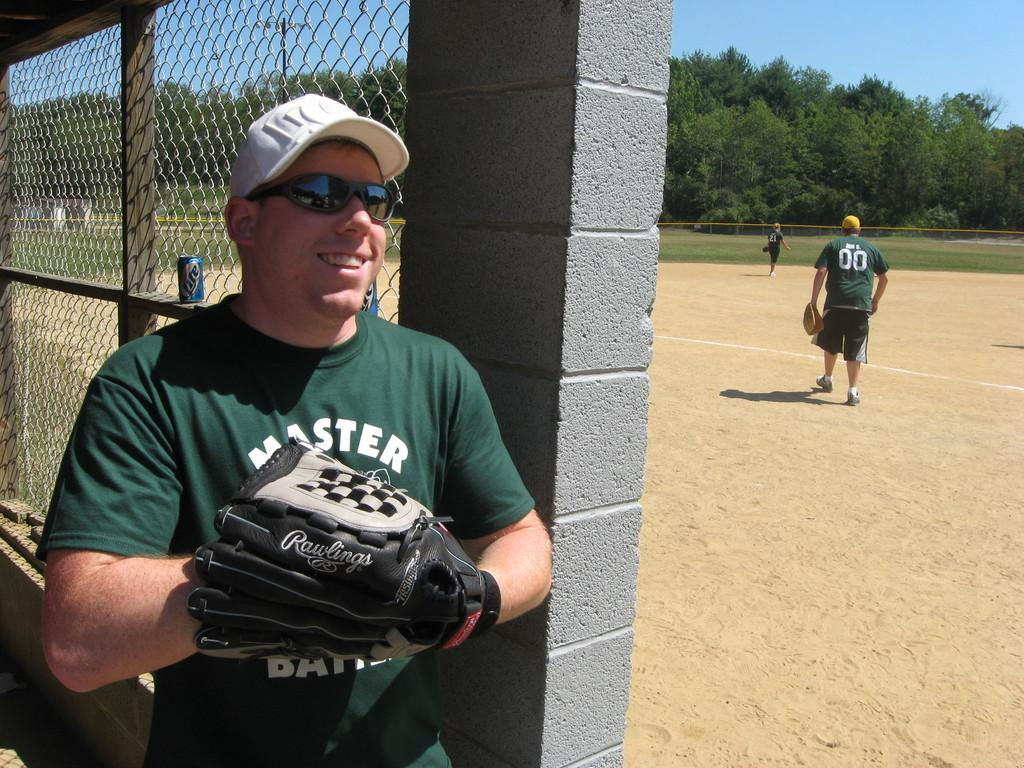<image>
Relay a brief, clear account of the picture shown. a guy with a white hat that is holding a glove and a Master shirt 